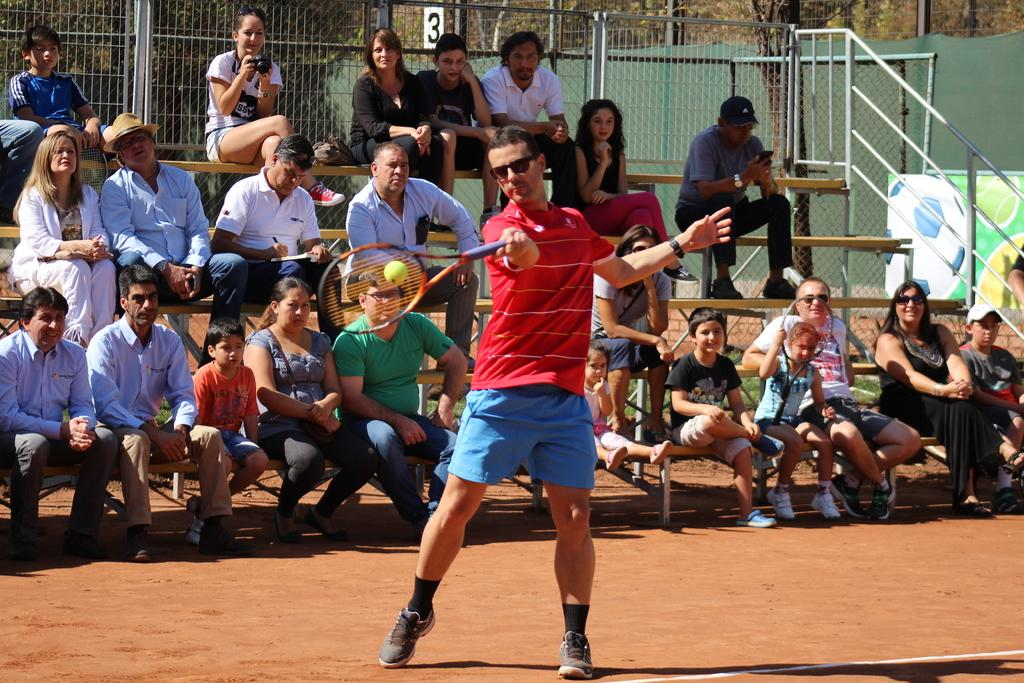<image>
Provide a brief description of the given image. A tennis match being played with the number 3 behind people watching. 